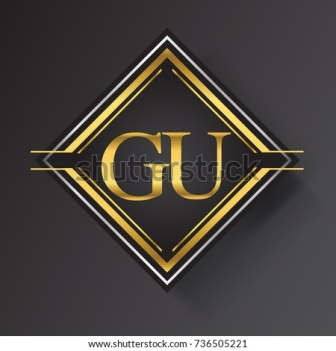The design seems very regal. Can you describe what a modern-day company using this emblem might be like? A modern-day company using this emblem might be a high-end, upscale business, possibly a luxury fashion brand or a bespoke estate management firm. This company would likely have an air of exclusivity and high status, catering to a clientele that values premium quality and exquisite craftsmanship. Their brand would emphasize attention to detail, heritage, and an elevated sense of style. As a symbol, the 'GU' emblem would instill a sense of trust and superiority, a mark that their products or services stand at the zenith of luxury. I'd imagine them organizing lavish events, don’t you think? Absolutely. This company would host events in opulent settings, creating unforgettable experiences for their select clients. Picture grand ballrooms, couture fashion shows, and art exhibitions featuring renowned personalities and artisans. Their gatherings would not just be about luxury but celebrating a certain joie de vivre, making each event a testament to their brand’s legacy and extraordinary standards. What if this emblem was part of a fantasy world? How would it fit in? In a fantasy world, this emblem could belong to an ancient order of wizards known as the 'Guardians of Unity (GU)'. The gold-on-black motif would symbolize their mastery over powerful, arcane energies and their noble quest to maintain balance across the realms. The emblem would be etched on their magical artifacts, armor, and scrolls, signifying unity and mastery. These wizards might dwell in a hidden, enchanted citadel, weaving spells of immense potency and delving into mystical lore to protect their kingdom from chaos and darkness. In folklore, their symbol would be revered and feared, a timeless reminder of their unparalleled abilities and their wisdom. 